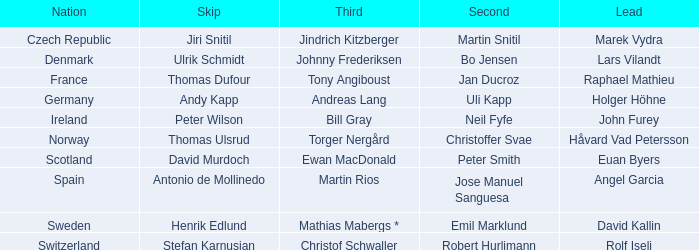Which Third has a Nation of scotland? Ewan MacDonald. 